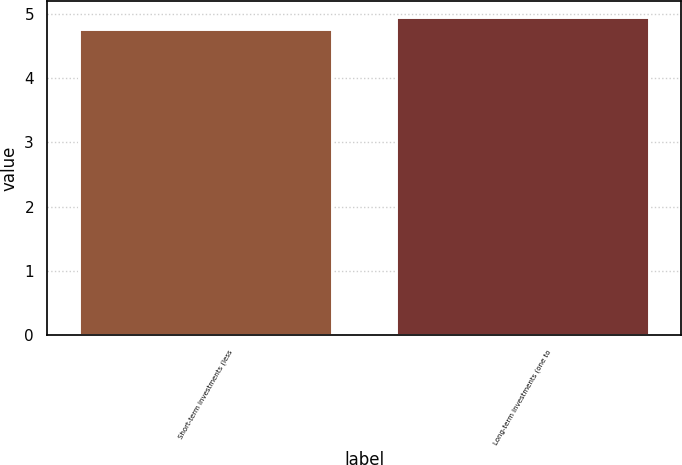Convert chart to OTSL. <chart><loc_0><loc_0><loc_500><loc_500><bar_chart><fcel>Short-term investments (less<fcel>Long-term investments (one to<nl><fcel>4.76<fcel>4.95<nl></chart> 